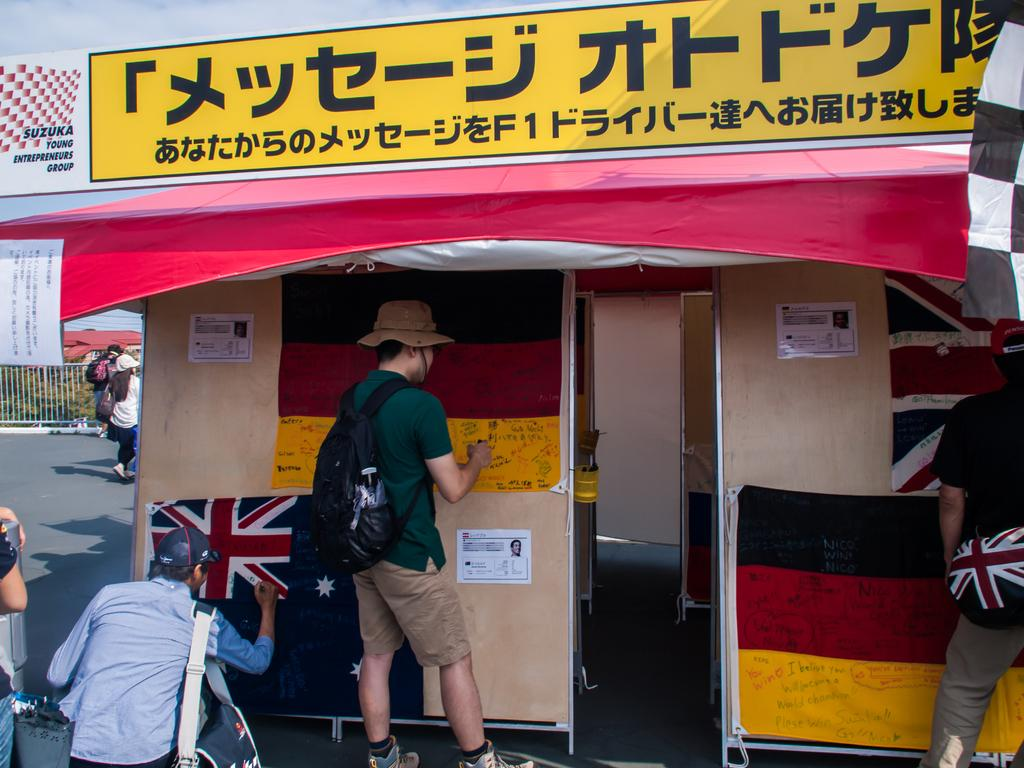<image>
Render a clear and concise summary of the photo. People have written Nico Win on a flag outside a building. 